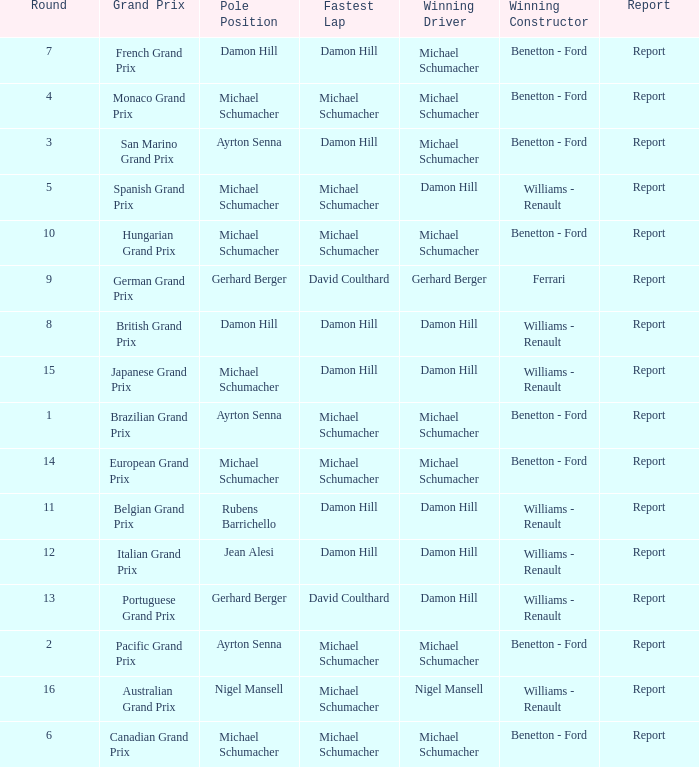Name the lowest round for when pole position and winning driver is michael schumacher 4.0. 